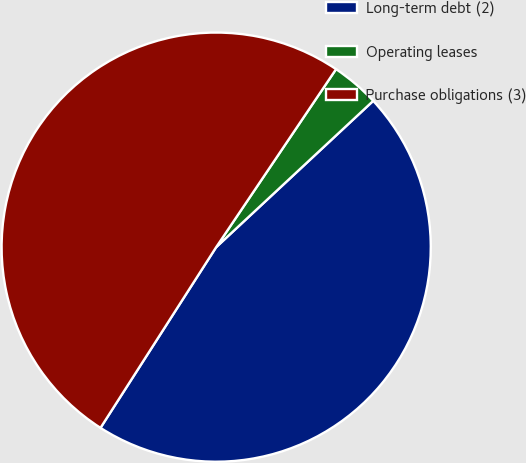Convert chart. <chart><loc_0><loc_0><loc_500><loc_500><pie_chart><fcel>Long-term debt (2)<fcel>Operating leases<fcel>Purchase obligations (3)<nl><fcel>46.0%<fcel>3.63%<fcel>50.37%<nl></chart> 